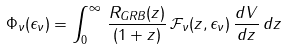<formula> <loc_0><loc_0><loc_500><loc_500>\Phi _ { \nu } ( \epsilon _ { \nu } ) = \int _ { 0 } ^ { \infty } \, \frac { R _ { G R B } ( z ) } { ( 1 + z ) } \, \mathcal { F } _ { \nu } ( z , \epsilon _ { \nu } ) \, \frac { d V } { d z } \, d z</formula> 